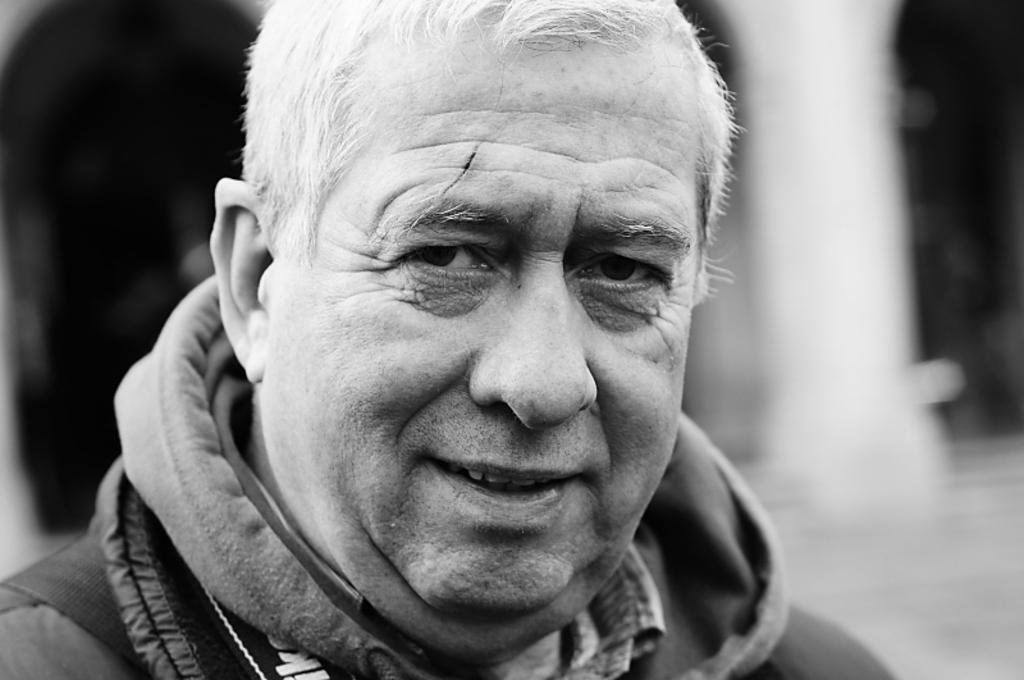What is the color scheme of the image? The image is black and white. Can you describe the main subject in the image? There is a person in the image. What can be observed about the background of the image? The background of the image is blurred. What language is the person speaking in the image? There is no indication of the person speaking in the image, nor is there any information about the language they might be speaking. 